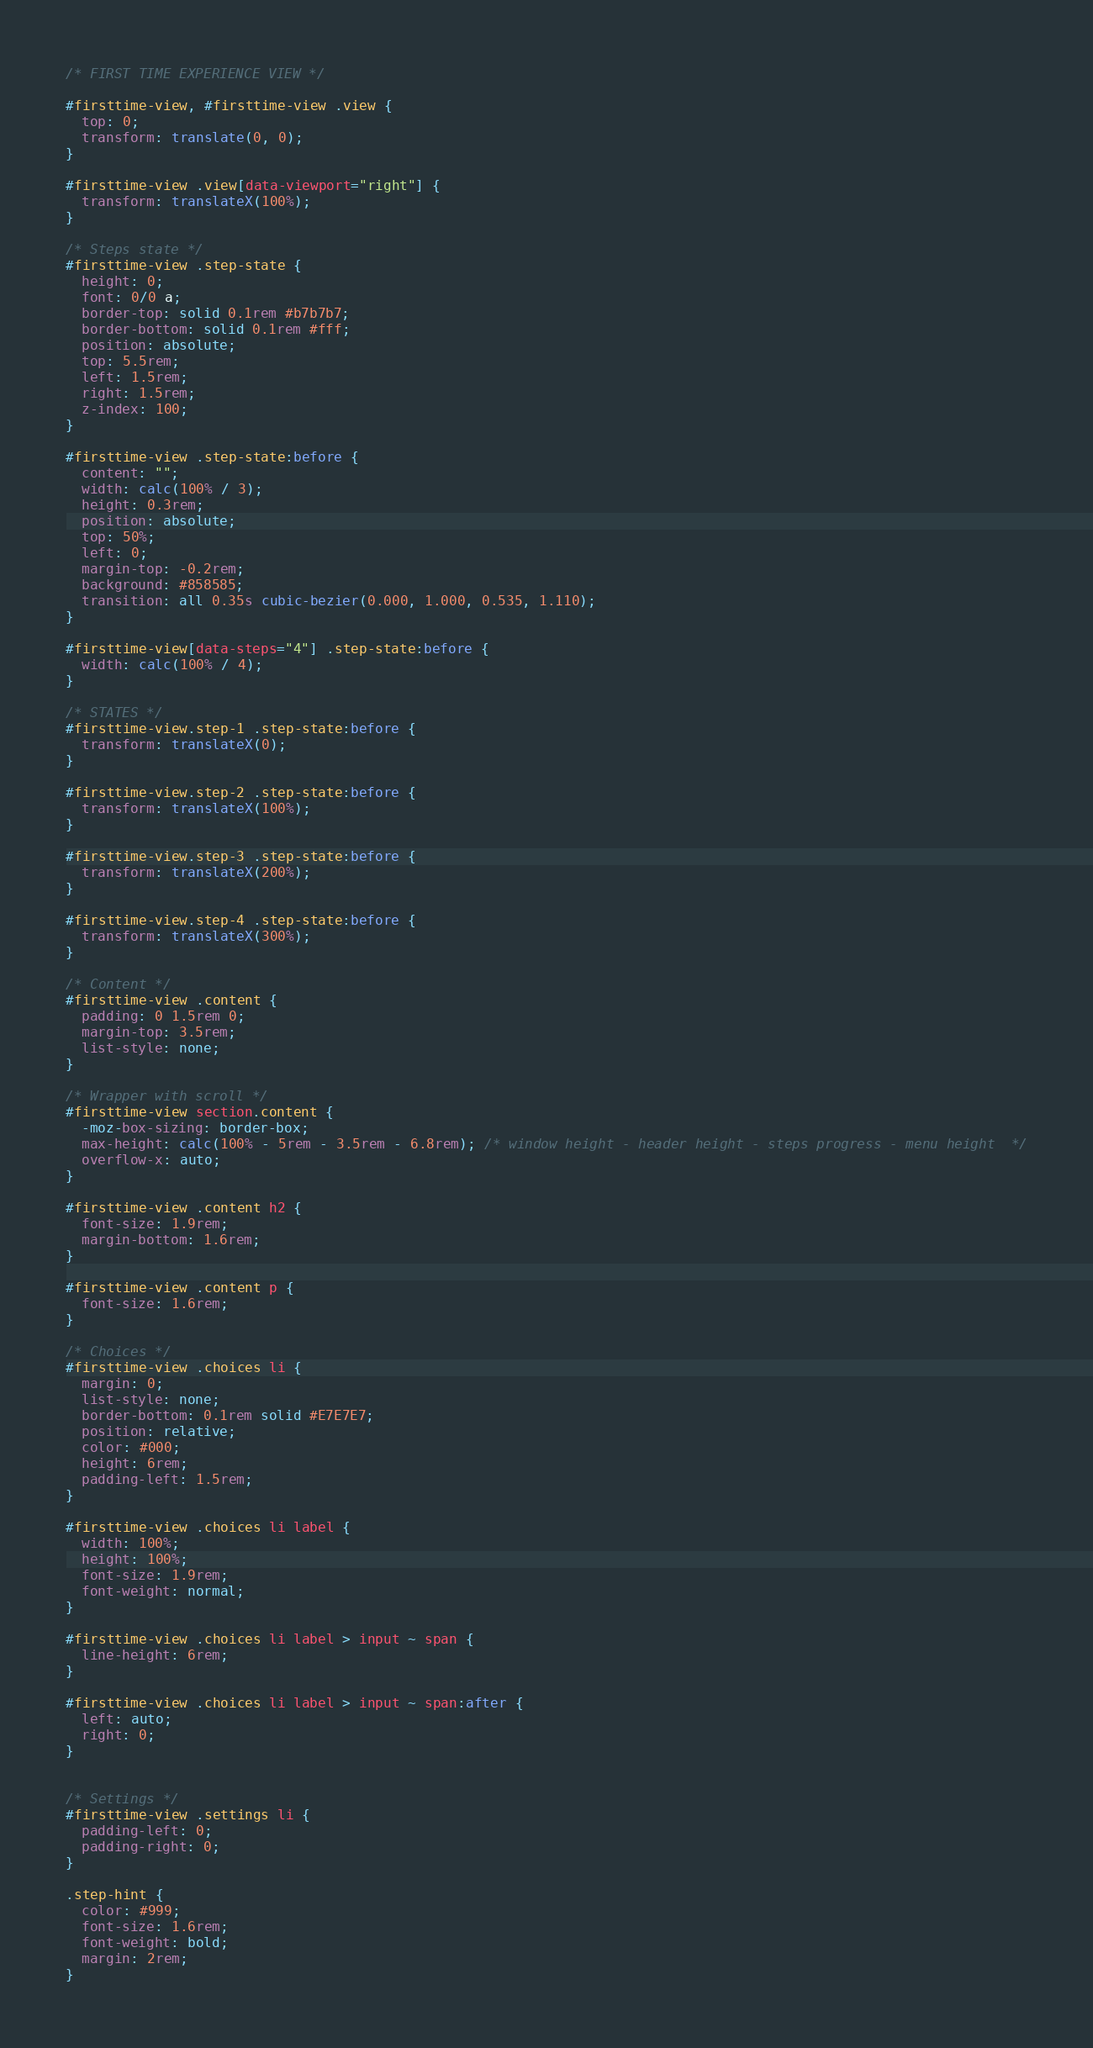Convert code to text. <code><loc_0><loc_0><loc_500><loc_500><_CSS_>/* FIRST TIME EXPERIENCE VIEW */

#firsttime-view, #firsttime-view .view {
  top: 0;
  transform: translate(0, 0);
}

#firsttime-view .view[data-viewport="right"] {
  transform: translateX(100%);
}

/* Steps state */
#firsttime-view .step-state {
  height: 0;
  font: 0/0 a;
  border-top: solid 0.1rem #b7b7b7;
  border-bottom: solid 0.1rem #fff;
  position: absolute;
  top: 5.5rem;
  left: 1.5rem;
  right: 1.5rem;
  z-index: 100;
}

#firsttime-view .step-state:before {
  content: "";
  width: calc(100% / 3);
  height: 0.3rem;
  position: absolute;
  top: 50%;
  left: 0;
  margin-top: -0.2rem;
  background: #858585;
  transition: all 0.35s cubic-bezier(0.000, 1.000, 0.535, 1.110);
}

#firsttime-view[data-steps="4"] .step-state:before {
  width: calc(100% / 4);
}

/* STATES */
#firsttime-view.step-1 .step-state:before {
  transform: translateX(0);
}

#firsttime-view.step-2 .step-state:before {
  transform: translateX(100%);
}

#firsttime-view.step-3 .step-state:before {
  transform: translateX(200%);
}

#firsttime-view.step-4 .step-state:before {
  transform: translateX(300%);
}

/* Content */
#firsttime-view .content {
  padding: 0 1.5rem 0;
  margin-top: 3.5rem;
  list-style: none;
}

/* Wrapper with scroll */
#firsttime-view section.content {
  -moz-box-sizing: border-box;
  max-height: calc(100% - 5rem - 3.5rem - 6.8rem); /* window height - header height - steps progress - menu height  */
  overflow-x: auto;
}

#firsttime-view .content h2 {
  font-size: 1.9rem;
  margin-bottom: 1.6rem;
}

#firsttime-view .content p {
  font-size: 1.6rem;
}

/* Choices */
#firsttime-view .choices li {
  margin: 0;
  list-style: none;
  border-bottom: 0.1rem solid #E7E7E7;
  position: relative;
  color: #000;
  height: 6rem;
  padding-left: 1.5rem;
}

#firsttime-view .choices li label {
  width: 100%;
  height: 100%;
  font-size: 1.9rem;
  font-weight: normal;
}

#firsttime-view .choices li label > input ~ span {
  line-height: 6rem;
}

#firsttime-view .choices li label > input ~ span:after {
  left: auto;
  right: 0;
}


/* Settings */
#firsttime-view .settings li {
  padding-left: 0;
  padding-right: 0;
}

.step-hint {
  color: #999;
  font-size: 1.6rem;
  font-weight: bold;
  margin: 2rem;
}
</code> 